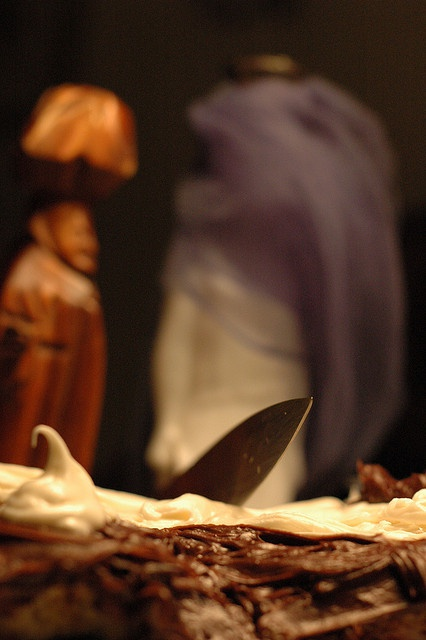Describe the objects in this image and their specific colors. I can see cake in black, maroon, brown, and khaki tones and knife in black, maroon, and olive tones in this image. 